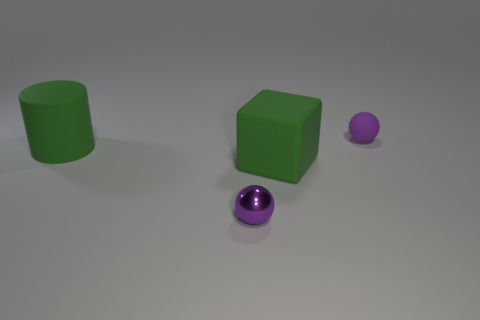Add 3 small purple rubber balls. How many objects exist? 7 Subtract 1 cylinders. How many cylinders are left? 0 Subtract all cylinders. How many objects are left? 3 Add 4 purple matte things. How many purple matte things are left? 5 Add 4 green rubber blocks. How many green rubber blocks exist? 5 Subtract 0 purple blocks. How many objects are left? 4 Subtract all brown cylinders. Subtract all blue blocks. How many cylinders are left? 1 Subtract all purple metallic things. Subtract all small rubber balls. How many objects are left? 2 